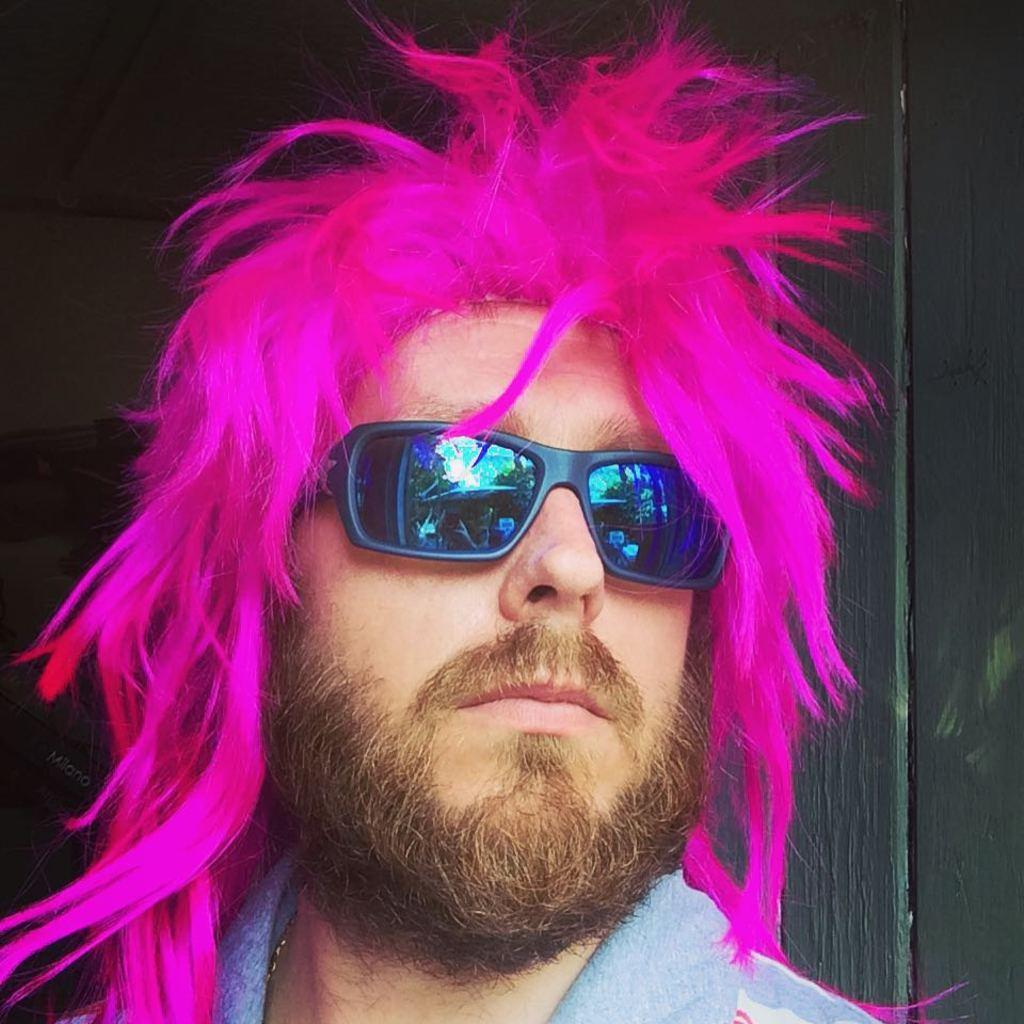Who is present in the image? There is a man in the image. What is unique about the man's appearance? The man has pink hair. What is the man wearing on his face? The man is wearing goggles. What can be observed about the background of the image? The background of the image is dark. What is the man's belief about the importance of rubbing his goggles in the image? There is no indication in the image of the man's beliefs or actions related to rubbing his goggles. 